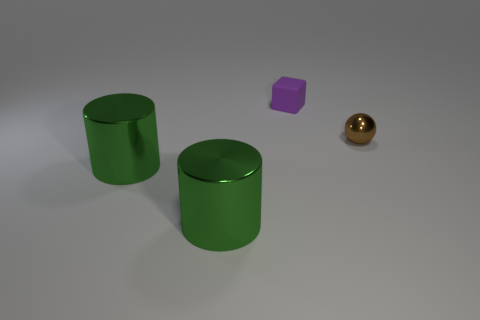What number of tiny objects are either green shiny blocks or cylinders?
Make the answer very short. 0. The rubber thing has what size?
Your answer should be compact. Small. Do the brown sphere and the object behind the small brown thing have the same size?
Provide a succinct answer. Yes. What number of green things are small metal spheres or large metal objects?
Your answer should be compact. 2. What number of tiny brown cylinders are there?
Your answer should be very brief. 0. What size is the thing to the right of the block?
Make the answer very short. Small. Do the purple rubber object and the shiny ball have the same size?
Provide a succinct answer. Yes. What number of things are yellow rubber cubes or objects that are on the left side of the tiny matte block?
Offer a very short reply. 2. What material is the small brown thing?
Provide a short and direct response. Metal. Are there any other things of the same color as the matte cube?
Provide a succinct answer. No. 